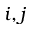<formula> <loc_0><loc_0><loc_500><loc_500>i , j</formula> 